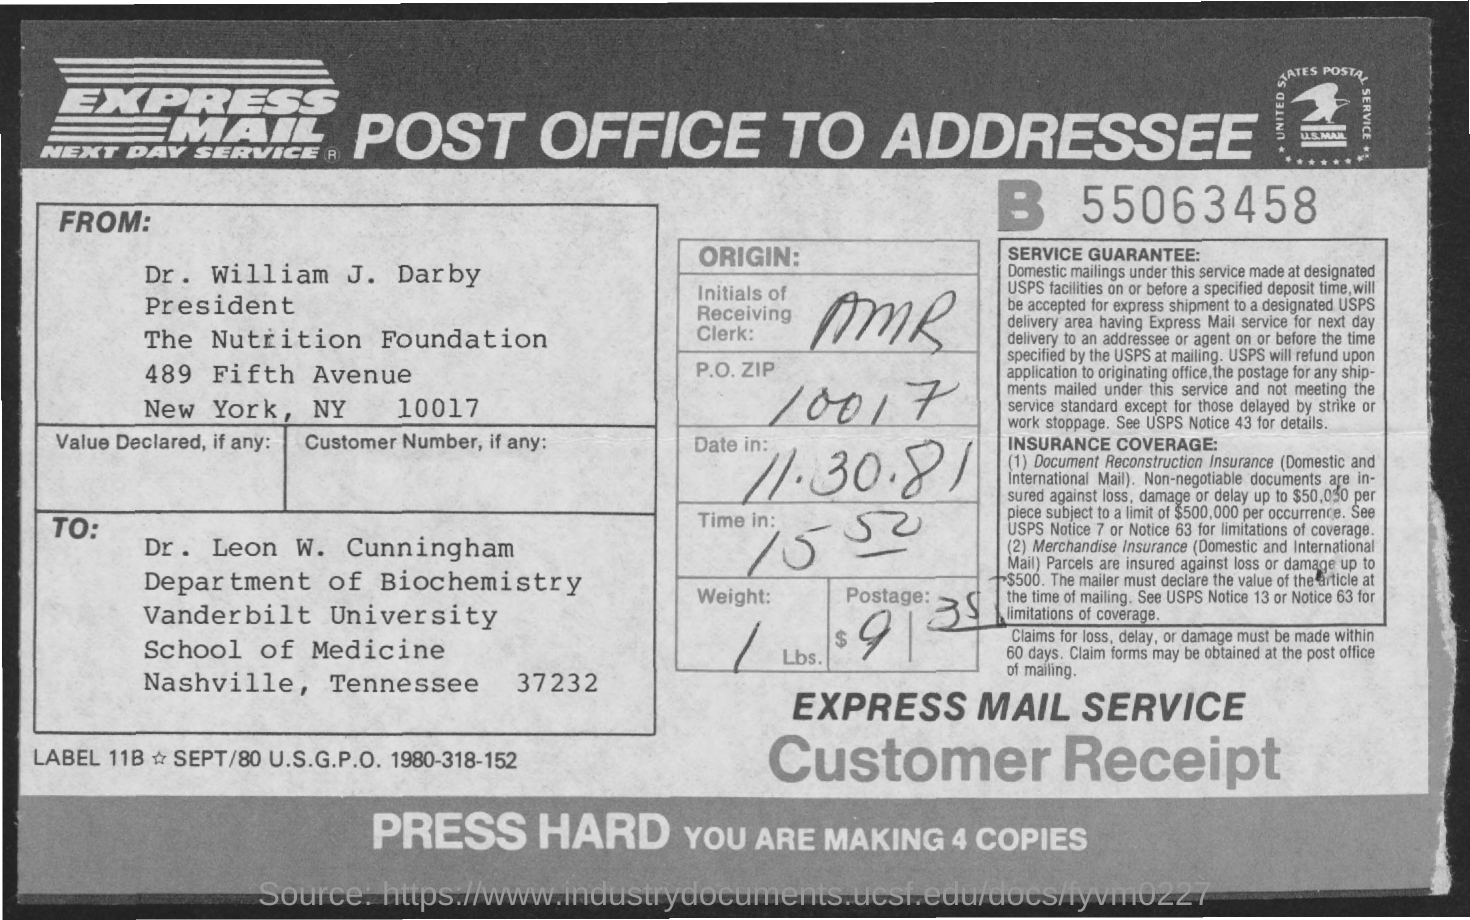Outline some significant characteristics in this image. The P.O. Zip is 10017. The weight is 1 pound. What is the date? It is November 30th, 1981. The initials of the receiving clerk are AMR. The postage amount is $9-$35. 